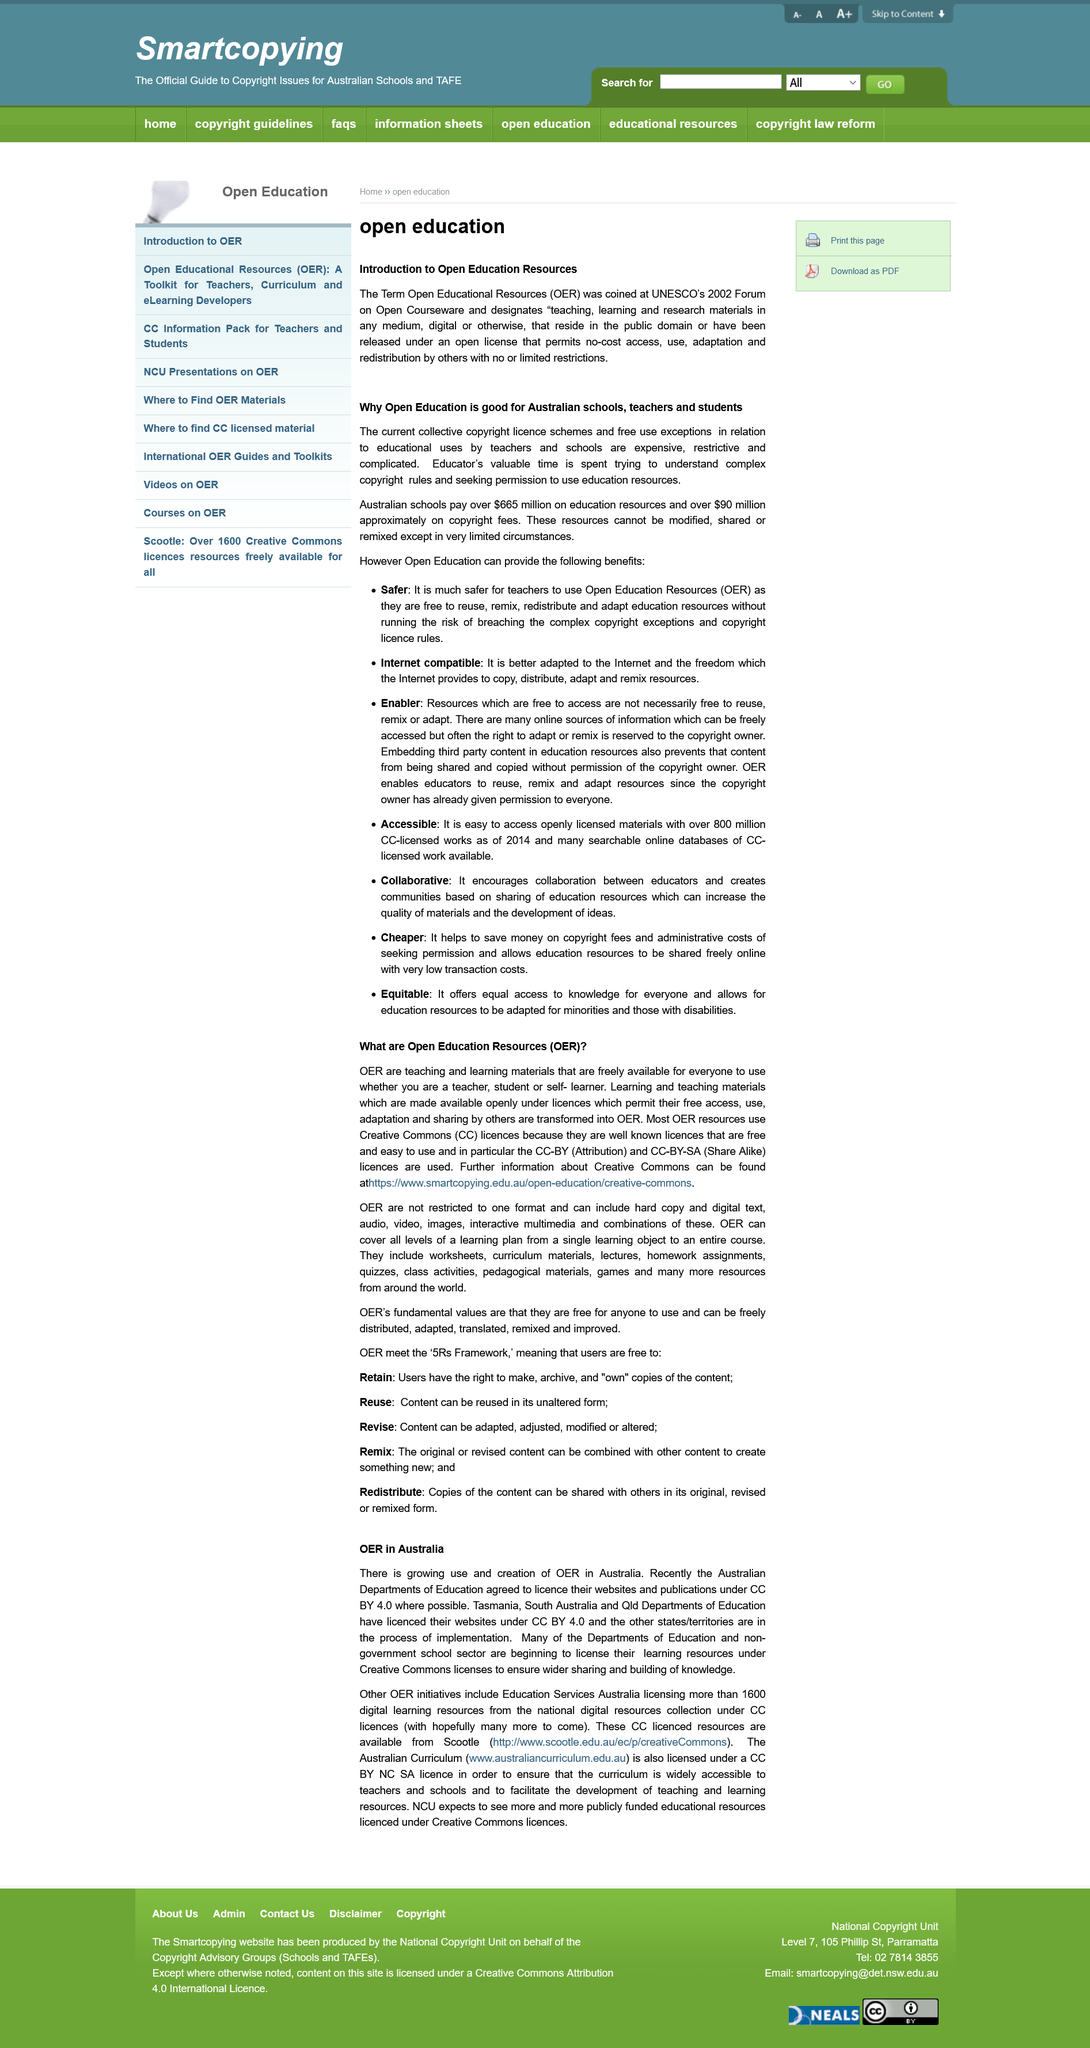Point out several critical features in this image. The first word of the third bullet point is 'Enabler.' Open Education Resources are freely available for everyone to use, as they are. The National Centre for Universities and Business (NCU) anticipates an increasing trend of publicly funded educational resources being made available under Creative Commons licenses. There are other OER initiatives, such as the Education Services Australia licensing more than 1600 digital learning resources from the national digital resources collection under CC licenses. Open Educational Resources (OER) have been widely recognized by UNESCO since 2020, and their significance has become increasingly relevant to Australia due to the expensive, restrictive, and complex nature of the current collective copyright licensing schemes and free use exceptions for educational purposes, which require teachers to spend valuable time deciphering the rules. 